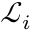<formula> <loc_0><loc_0><loc_500><loc_500>\mathcal { L } _ { i }</formula> 